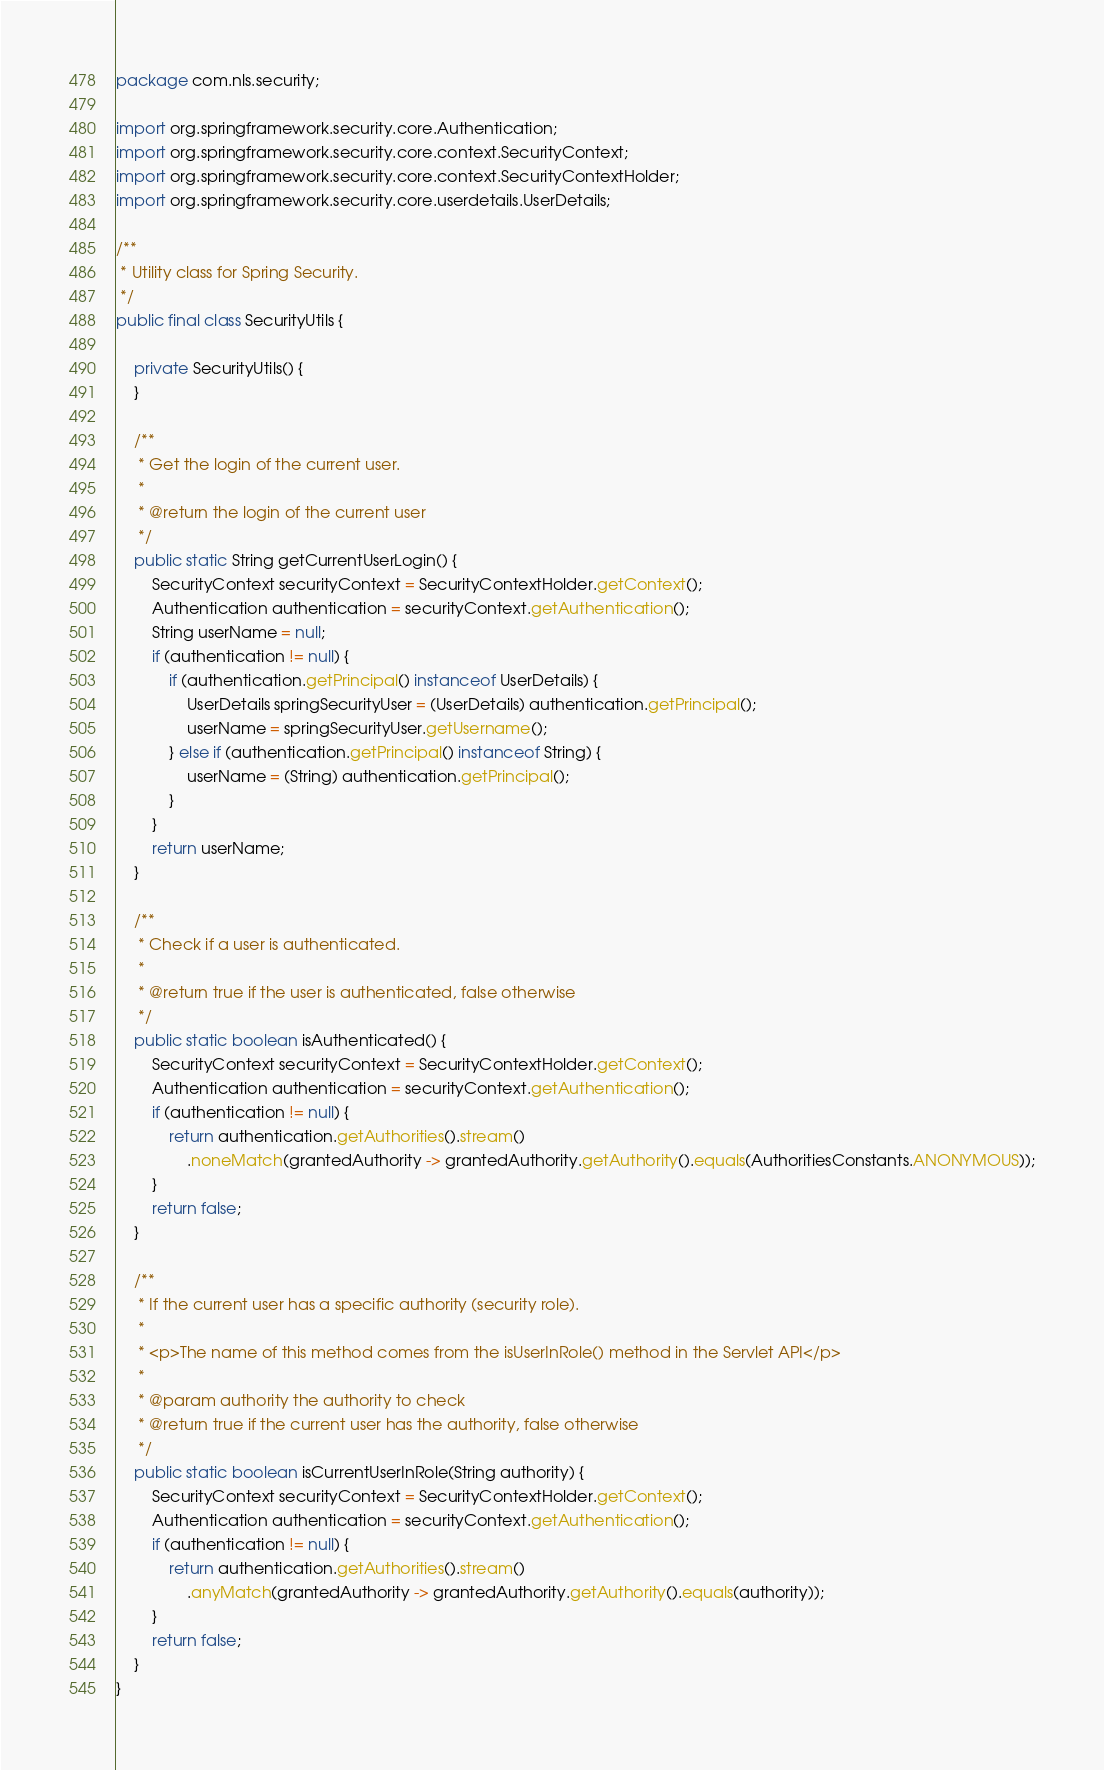<code> <loc_0><loc_0><loc_500><loc_500><_Java_>package com.nls.security;

import org.springframework.security.core.Authentication;
import org.springframework.security.core.context.SecurityContext;
import org.springframework.security.core.context.SecurityContextHolder;
import org.springframework.security.core.userdetails.UserDetails;

/**
 * Utility class for Spring Security.
 */
public final class SecurityUtils {
    
    private SecurityUtils() {
    }

    /**
     * Get the login of the current user.
     *
     * @return the login of the current user
     */
    public static String getCurrentUserLogin() {
        SecurityContext securityContext = SecurityContextHolder.getContext();
        Authentication authentication = securityContext.getAuthentication();
        String userName = null;
        if (authentication != null) {
            if (authentication.getPrincipal() instanceof UserDetails) {
                UserDetails springSecurityUser = (UserDetails) authentication.getPrincipal();
                userName = springSecurityUser.getUsername();
            } else if (authentication.getPrincipal() instanceof String) {
                userName = (String) authentication.getPrincipal();
            }
        }
        return userName;
    }
    
    /**
     * Check if a user is authenticated.
     *
     * @return true if the user is authenticated, false otherwise
     */
    public static boolean isAuthenticated() {
        SecurityContext securityContext = SecurityContextHolder.getContext();
        Authentication authentication = securityContext.getAuthentication();
        if (authentication != null) {
            return authentication.getAuthorities().stream()
                .noneMatch(grantedAuthority -> grantedAuthority.getAuthority().equals(AuthoritiesConstants.ANONYMOUS));
        }
        return false;
    }

    /**
     * If the current user has a specific authority (security role).
     *
     * <p>The name of this method comes from the isUserInRole() method in the Servlet API</p>
     *
     * @param authority the authority to check
     * @return true if the current user has the authority, false otherwise
     */
    public static boolean isCurrentUserInRole(String authority) {
        SecurityContext securityContext = SecurityContextHolder.getContext();
        Authentication authentication = securityContext.getAuthentication();
        if (authentication != null) {
            return authentication.getAuthorities().stream()
                .anyMatch(grantedAuthority -> grantedAuthority.getAuthority().equals(authority));
        }
        return false;
    }
}
</code> 